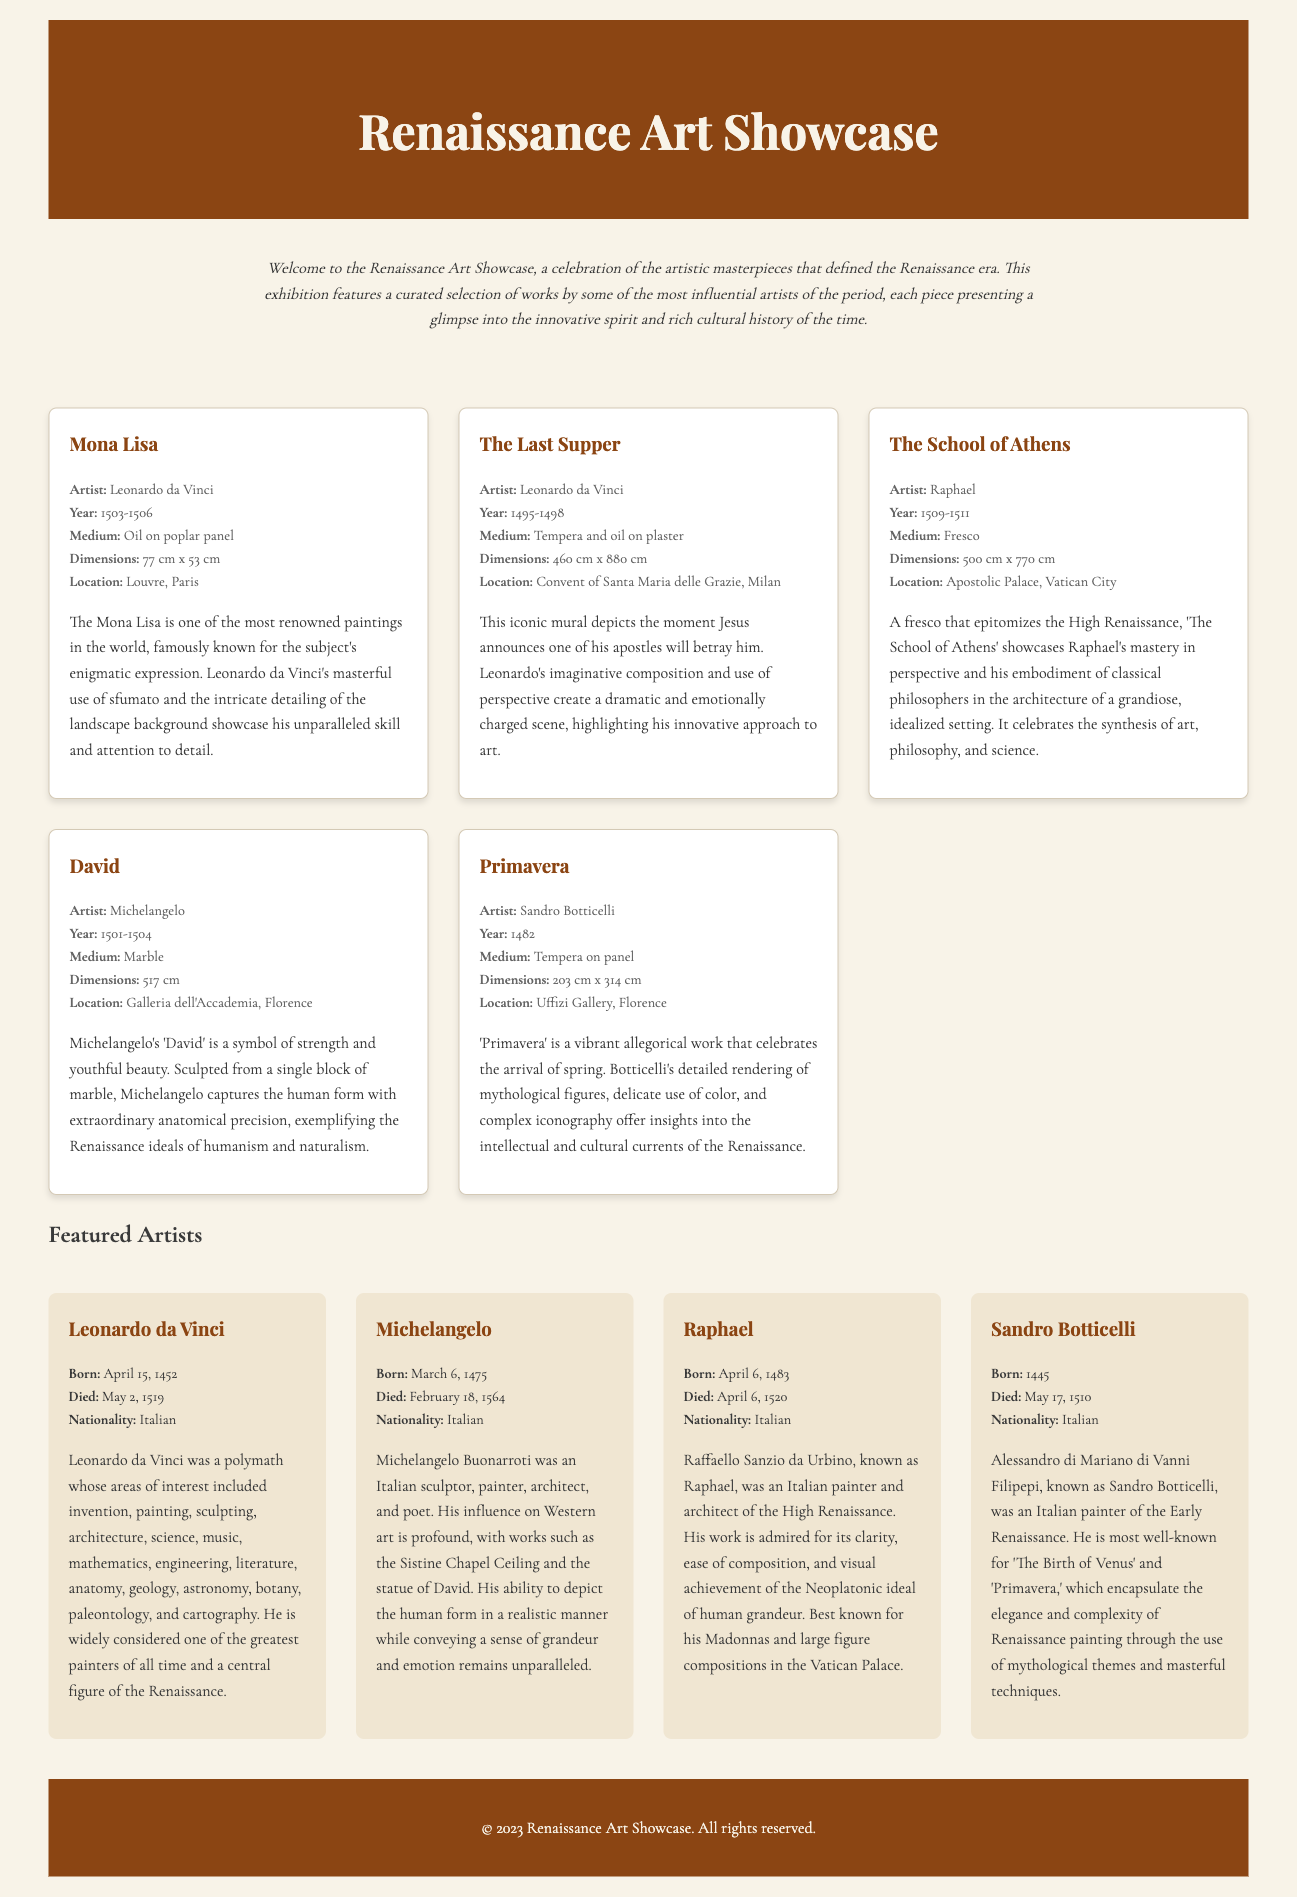What is the name of the exhibition? The name of the exhibition is mentioned in the header of the document.
Answer: Renaissance Art Showcase Who is the artist of the "Mona Lisa"? The artist's name is specified under the artwork section for "Mona Lisa".
Answer: Leonardo da Vinci What is the medium of "The Last Supper"? The document lists the medium used for "The Last Supper" in its description.
Answer: Tempera and oil on plaster What are the dimensions of "David"? The dimensions of "David" are provided in the artwork details.
Answer: 517 cm Which artist created "Primavera"? The artist's name is mentioned alongside the artwork details for "Primavera".
Answer: Sandro Botticelli What year was Raphael born? The birth year of Raphael is detailed in the artist's section.
Answer: 1483 Which artwork is located in the Louvre, Paris? The location is specified for one of the artworks in the document.
Answer: Mona Lisa What is a key theme depicted in "The School of Athens"? The themes are described in the artwork's paragraph, requiring reasoning over the content.
Answer: Synthesis of art, philosophy, and science Which artist is known as a polymath? The description of artists provides this information, requiring knowledge of their contributions.
Answer: Leonardo da Vinci 